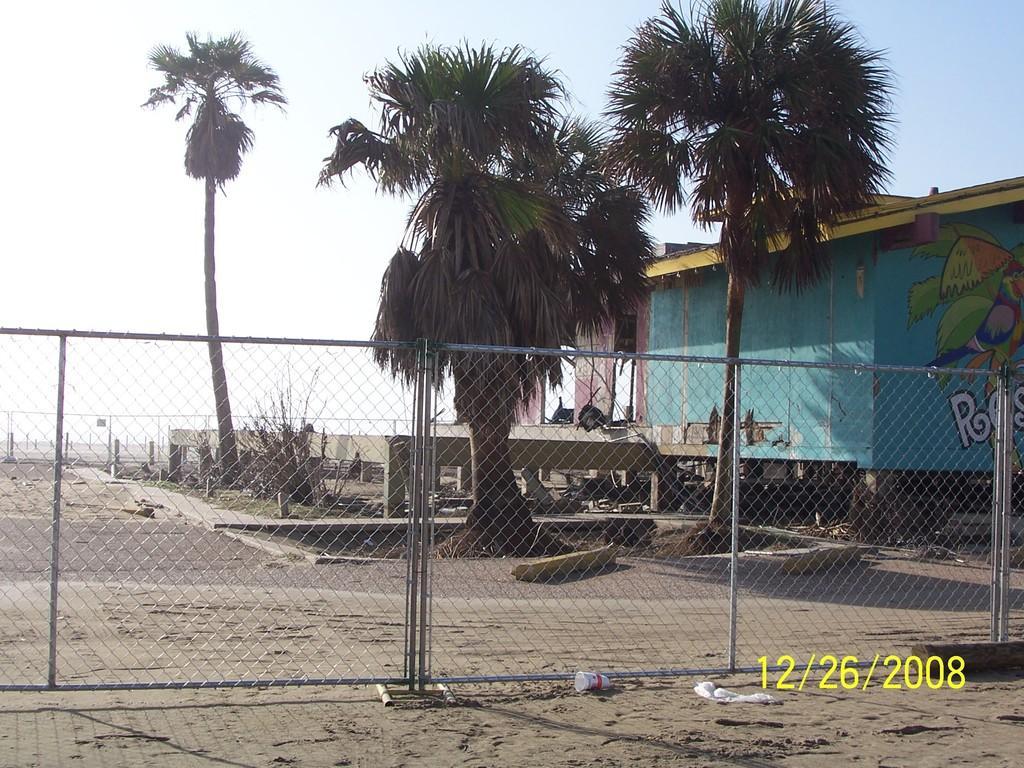Describe this image in one or two sentences. In this image there are trees. On the right we can see a shed. There are fences. In the background there is sky. 